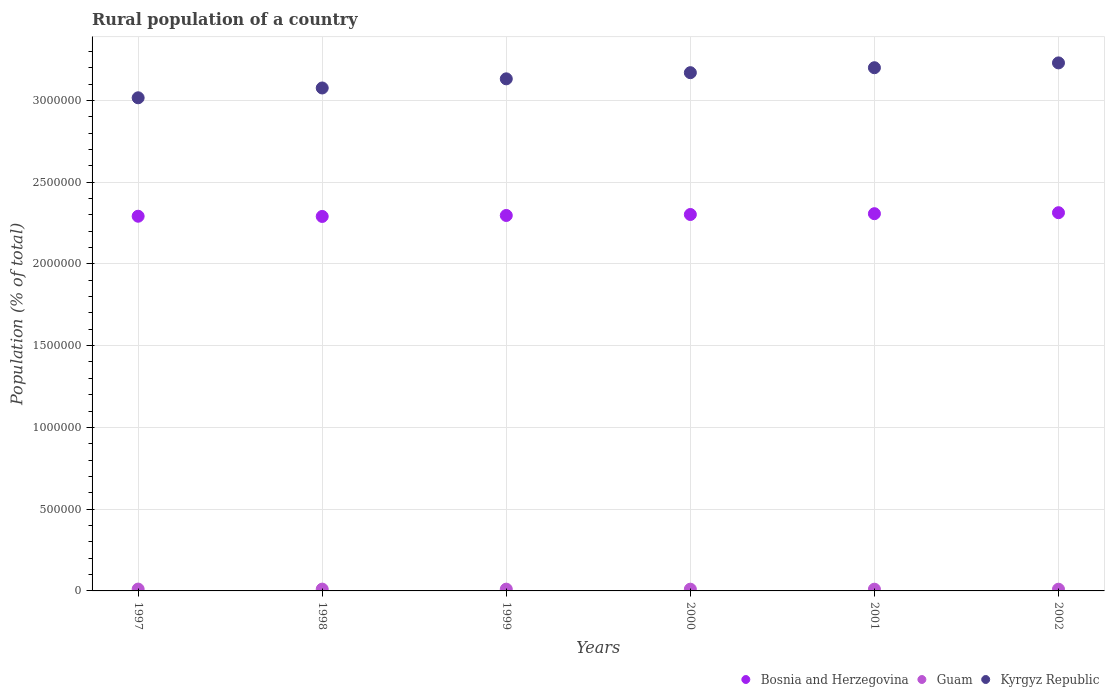How many different coloured dotlines are there?
Offer a very short reply. 3. Is the number of dotlines equal to the number of legend labels?
Keep it short and to the point. Yes. What is the rural population in Kyrgyz Republic in 2001?
Offer a very short reply. 3.20e+06. Across all years, what is the maximum rural population in Bosnia and Herzegovina?
Provide a succinct answer. 2.31e+06. Across all years, what is the minimum rural population in Kyrgyz Republic?
Ensure brevity in your answer.  3.02e+06. What is the total rural population in Bosnia and Herzegovina in the graph?
Provide a succinct answer. 1.38e+07. What is the difference between the rural population in Kyrgyz Republic in 1998 and that in 2002?
Make the answer very short. -1.53e+05. What is the difference between the rural population in Bosnia and Herzegovina in 1999 and the rural population in Kyrgyz Republic in 2000?
Your answer should be compact. -8.73e+05. What is the average rural population in Guam per year?
Your answer should be compact. 1.08e+04. In the year 1999, what is the difference between the rural population in Guam and rural population in Kyrgyz Republic?
Provide a short and direct response. -3.12e+06. What is the ratio of the rural population in Kyrgyz Republic in 1999 to that in 2001?
Keep it short and to the point. 0.98. Is the difference between the rural population in Guam in 1998 and 2000 greater than the difference between the rural population in Kyrgyz Republic in 1998 and 2000?
Give a very brief answer. Yes. What is the difference between the highest and the second highest rural population in Bosnia and Herzegovina?
Provide a short and direct response. 6022. What is the difference between the highest and the lowest rural population in Guam?
Keep it short and to the point. 771. Is the sum of the rural population in Kyrgyz Republic in 1998 and 2000 greater than the maximum rural population in Bosnia and Herzegovina across all years?
Provide a succinct answer. Yes. Is it the case that in every year, the sum of the rural population in Guam and rural population in Kyrgyz Republic  is greater than the rural population in Bosnia and Herzegovina?
Your answer should be very brief. Yes. Does the rural population in Bosnia and Herzegovina monotonically increase over the years?
Provide a succinct answer. No. What is the difference between two consecutive major ticks on the Y-axis?
Give a very brief answer. 5.00e+05. Are the values on the major ticks of Y-axis written in scientific E-notation?
Offer a very short reply. No. Does the graph contain grids?
Your response must be concise. Yes. Where does the legend appear in the graph?
Your answer should be very brief. Bottom right. How are the legend labels stacked?
Offer a very short reply. Horizontal. What is the title of the graph?
Ensure brevity in your answer.  Rural population of a country. Does "Ghana" appear as one of the legend labels in the graph?
Offer a very short reply. No. What is the label or title of the Y-axis?
Make the answer very short. Population (% of total). What is the Population (% of total) in Bosnia and Herzegovina in 1997?
Your answer should be very brief. 2.29e+06. What is the Population (% of total) of Guam in 1997?
Make the answer very short. 1.13e+04. What is the Population (% of total) of Kyrgyz Republic in 1997?
Provide a short and direct response. 3.02e+06. What is the Population (% of total) of Bosnia and Herzegovina in 1998?
Keep it short and to the point. 2.29e+06. What is the Population (% of total) of Guam in 1998?
Offer a terse response. 1.11e+04. What is the Population (% of total) in Kyrgyz Republic in 1998?
Keep it short and to the point. 3.08e+06. What is the Population (% of total) in Bosnia and Herzegovina in 1999?
Offer a very short reply. 2.30e+06. What is the Population (% of total) in Guam in 1999?
Ensure brevity in your answer.  1.09e+04. What is the Population (% of total) in Kyrgyz Republic in 1999?
Ensure brevity in your answer.  3.13e+06. What is the Population (% of total) of Bosnia and Herzegovina in 2000?
Ensure brevity in your answer.  2.30e+06. What is the Population (% of total) in Guam in 2000?
Make the answer very short. 1.07e+04. What is the Population (% of total) in Kyrgyz Republic in 2000?
Your answer should be compact. 3.17e+06. What is the Population (% of total) of Bosnia and Herzegovina in 2001?
Give a very brief answer. 2.31e+06. What is the Population (% of total) of Guam in 2001?
Offer a terse response. 1.06e+04. What is the Population (% of total) of Kyrgyz Republic in 2001?
Offer a terse response. 3.20e+06. What is the Population (% of total) in Bosnia and Herzegovina in 2002?
Your answer should be very brief. 2.31e+06. What is the Population (% of total) of Guam in 2002?
Your answer should be compact. 1.05e+04. What is the Population (% of total) in Kyrgyz Republic in 2002?
Keep it short and to the point. 3.23e+06. Across all years, what is the maximum Population (% of total) of Bosnia and Herzegovina?
Make the answer very short. 2.31e+06. Across all years, what is the maximum Population (% of total) in Guam?
Offer a very short reply. 1.13e+04. Across all years, what is the maximum Population (% of total) in Kyrgyz Republic?
Keep it short and to the point. 3.23e+06. Across all years, what is the minimum Population (% of total) in Bosnia and Herzegovina?
Offer a terse response. 2.29e+06. Across all years, what is the minimum Population (% of total) in Guam?
Make the answer very short. 1.05e+04. Across all years, what is the minimum Population (% of total) of Kyrgyz Republic?
Your response must be concise. 3.02e+06. What is the total Population (% of total) in Bosnia and Herzegovina in the graph?
Your answer should be compact. 1.38e+07. What is the total Population (% of total) of Guam in the graph?
Make the answer very short. 6.49e+04. What is the total Population (% of total) of Kyrgyz Republic in the graph?
Your response must be concise. 1.88e+07. What is the difference between the Population (% of total) of Bosnia and Herzegovina in 1997 and that in 1998?
Your answer should be compact. 1302. What is the difference between the Population (% of total) in Guam in 1997 and that in 1998?
Give a very brief answer. 187. What is the difference between the Population (% of total) of Kyrgyz Republic in 1997 and that in 1998?
Offer a very short reply. -6.00e+04. What is the difference between the Population (% of total) of Bosnia and Herzegovina in 1997 and that in 1999?
Give a very brief answer. -4642. What is the difference between the Population (% of total) in Guam in 1997 and that in 1999?
Provide a succinct answer. 393. What is the difference between the Population (% of total) in Kyrgyz Republic in 1997 and that in 1999?
Make the answer very short. -1.16e+05. What is the difference between the Population (% of total) of Bosnia and Herzegovina in 1997 and that in 2000?
Your response must be concise. -1.06e+04. What is the difference between the Population (% of total) in Guam in 1997 and that in 2000?
Give a very brief answer. 580. What is the difference between the Population (% of total) in Kyrgyz Republic in 1997 and that in 2000?
Your answer should be very brief. -1.54e+05. What is the difference between the Population (% of total) in Bosnia and Herzegovina in 1997 and that in 2001?
Offer a terse response. -1.56e+04. What is the difference between the Population (% of total) of Guam in 1997 and that in 2001?
Keep it short and to the point. 668. What is the difference between the Population (% of total) of Kyrgyz Republic in 1997 and that in 2001?
Ensure brevity in your answer.  -1.84e+05. What is the difference between the Population (% of total) of Bosnia and Herzegovina in 1997 and that in 2002?
Offer a very short reply. -2.16e+04. What is the difference between the Population (% of total) in Guam in 1997 and that in 2002?
Give a very brief answer. 771. What is the difference between the Population (% of total) of Kyrgyz Republic in 1997 and that in 2002?
Provide a succinct answer. -2.13e+05. What is the difference between the Population (% of total) in Bosnia and Herzegovina in 1998 and that in 1999?
Make the answer very short. -5944. What is the difference between the Population (% of total) in Guam in 1998 and that in 1999?
Provide a succinct answer. 206. What is the difference between the Population (% of total) in Kyrgyz Republic in 1998 and that in 1999?
Provide a succinct answer. -5.59e+04. What is the difference between the Population (% of total) of Bosnia and Herzegovina in 1998 and that in 2000?
Provide a short and direct response. -1.19e+04. What is the difference between the Population (% of total) of Guam in 1998 and that in 2000?
Offer a terse response. 393. What is the difference between the Population (% of total) in Kyrgyz Republic in 1998 and that in 2000?
Ensure brevity in your answer.  -9.35e+04. What is the difference between the Population (% of total) in Bosnia and Herzegovina in 1998 and that in 2001?
Make the answer very short. -1.69e+04. What is the difference between the Population (% of total) in Guam in 1998 and that in 2001?
Provide a short and direct response. 481. What is the difference between the Population (% of total) in Kyrgyz Republic in 1998 and that in 2001?
Offer a very short reply. -1.24e+05. What is the difference between the Population (% of total) in Bosnia and Herzegovina in 1998 and that in 2002?
Provide a short and direct response. -2.29e+04. What is the difference between the Population (% of total) of Guam in 1998 and that in 2002?
Your answer should be compact. 584. What is the difference between the Population (% of total) of Kyrgyz Republic in 1998 and that in 2002?
Keep it short and to the point. -1.53e+05. What is the difference between the Population (% of total) of Bosnia and Herzegovina in 1999 and that in 2000?
Your response must be concise. -5947. What is the difference between the Population (% of total) in Guam in 1999 and that in 2000?
Keep it short and to the point. 187. What is the difference between the Population (% of total) in Kyrgyz Republic in 1999 and that in 2000?
Ensure brevity in your answer.  -3.76e+04. What is the difference between the Population (% of total) of Bosnia and Herzegovina in 1999 and that in 2001?
Ensure brevity in your answer.  -1.09e+04. What is the difference between the Population (% of total) in Guam in 1999 and that in 2001?
Offer a terse response. 275. What is the difference between the Population (% of total) of Kyrgyz Republic in 1999 and that in 2001?
Your answer should be compact. -6.79e+04. What is the difference between the Population (% of total) in Bosnia and Herzegovina in 1999 and that in 2002?
Provide a short and direct response. -1.69e+04. What is the difference between the Population (% of total) in Guam in 1999 and that in 2002?
Give a very brief answer. 378. What is the difference between the Population (% of total) of Kyrgyz Republic in 1999 and that in 2002?
Provide a short and direct response. -9.75e+04. What is the difference between the Population (% of total) of Bosnia and Herzegovina in 2000 and that in 2001?
Give a very brief answer. -4967. What is the difference between the Population (% of total) in Kyrgyz Republic in 2000 and that in 2001?
Give a very brief answer. -3.03e+04. What is the difference between the Population (% of total) in Bosnia and Herzegovina in 2000 and that in 2002?
Ensure brevity in your answer.  -1.10e+04. What is the difference between the Population (% of total) in Guam in 2000 and that in 2002?
Provide a succinct answer. 191. What is the difference between the Population (% of total) in Kyrgyz Republic in 2000 and that in 2002?
Your response must be concise. -5.99e+04. What is the difference between the Population (% of total) of Bosnia and Herzegovina in 2001 and that in 2002?
Give a very brief answer. -6022. What is the difference between the Population (% of total) in Guam in 2001 and that in 2002?
Provide a short and direct response. 103. What is the difference between the Population (% of total) of Kyrgyz Republic in 2001 and that in 2002?
Offer a very short reply. -2.96e+04. What is the difference between the Population (% of total) of Bosnia and Herzegovina in 1997 and the Population (% of total) of Guam in 1998?
Make the answer very short. 2.28e+06. What is the difference between the Population (% of total) in Bosnia and Herzegovina in 1997 and the Population (% of total) in Kyrgyz Republic in 1998?
Your response must be concise. -7.84e+05. What is the difference between the Population (% of total) of Guam in 1997 and the Population (% of total) of Kyrgyz Republic in 1998?
Your answer should be very brief. -3.06e+06. What is the difference between the Population (% of total) of Bosnia and Herzegovina in 1997 and the Population (% of total) of Guam in 1999?
Your response must be concise. 2.28e+06. What is the difference between the Population (% of total) of Bosnia and Herzegovina in 1997 and the Population (% of total) of Kyrgyz Republic in 1999?
Give a very brief answer. -8.40e+05. What is the difference between the Population (% of total) in Guam in 1997 and the Population (% of total) in Kyrgyz Republic in 1999?
Your response must be concise. -3.12e+06. What is the difference between the Population (% of total) in Bosnia and Herzegovina in 1997 and the Population (% of total) in Guam in 2000?
Ensure brevity in your answer.  2.28e+06. What is the difference between the Population (% of total) of Bosnia and Herzegovina in 1997 and the Population (% of total) of Kyrgyz Republic in 2000?
Offer a terse response. -8.78e+05. What is the difference between the Population (% of total) of Guam in 1997 and the Population (% of total) of Kyrgyz Republic in 2000?
Make the answer very short. -3.16e+06. What is the difference between the Population (% of total) of Bosnia and Herzegovina in 1997 and the Population (% of total) of Guam in 2001?
Your response must be concise. 2.28e+06. What is the difference between the Population (% of total) in Bosnia and Herzegovina in 1997 and the Population (% of total) in Kyrgyz Republic in 2001?
Your answer should be compact. -9.08e+05. What is the difference between the Population (% of total) in Guam in 1997 and the Population (% of total) in Kyrgyz Republic in 2001?
Your response must be concise. -3.19e+06. What is the difference between the Population (% of total) of Bosnia and Herzegovina in 1997 and the Population (% of total) of Guam in 2002?
Offer a very short reply. 2.28e+06. What is the difference between the Population (% of total) in Bosnia and Herzegovina in 1997 and the Population (% of total) in Kyrgyz Republic in 2002?
Your answer should be very brief. -9.38e+05. What is the difference between the Population (% of total) of Guam in 1997 and the Population (% of total) of Kyrgyz Republic in 2002?
Your answer should be compact. -3.22e+06. What is the difference between the Population (% of total) in Bosnia and Herzegovina in 1998 and the Population (% of total) in Guam in 1999?
Make the answer very short. 2.28e+06. What is the difference between the Population (% of total) in Bosnia and Herzegovina in 1998 and the Population (% of total) in Kyrgyz Republic in 1999?
Offer a terse response. -8.42e+05. What is the difference between the Population (% of total) in Guam in 1998 and the Population (% of total) in Kyrgyz Republic in 1999?
Ensure brevity in your answer.  -3.12e+06. What is the difference between the Population (% of total) in Bosnia and Herzegovina in 1998 and the Population (% of total) in Guam in 2000?
Provide a succinct answer. 2.28e+06. What is the difference between the Population (% of total) of Bosnia and Herzegovina in 1998 and the Population (% of total) of Kyrgyz Republic in 2000?
Your answer should be very brief. -8.79e+05. What is the difference between the Population (% of total) in Guam in 1998 and the Population (% of total) in Kyrgyz Republic in 2000?
Provide a succinct answer. -3.16e+06. What is the difference between the Population (% of total) of Bosnia and Herzegovina in 1998 and the Population (% of total) of Guam in 2001?
Offer a terse response. 2.28e+06. What is the difference between the Population (% of total) in Bosnia and Herzegovina in 1998 and the Population (% of total) in Kyrgyz Republic in 2001?
Keep it short and to the point. -9.10e+05. What is the difference between the Population (% of total) of Guam in 1998 and the Population (% of total) of Kyrgyz Republic in 2001?
Provide a short and direct response. -3.19e+06. What is the difference between the Population (% of total) of Bosnia and Herzegovina in 1998 and the Population (% of total) of Guam in 2002?
Provide a succinct answer. 2.28e+06. What is the difference between the Population (% of total) of Bosnia and Herzegovina in 1998 and the Population (% of total) of Kyrgyz Republic in 2002?
Make the answer very short. -9.39e+05. What is the difference between the Population (% of total) of Guam in 1998 and the Population (% of total) of Kyrgyz Republic in 2002?
Make the answer very short. -3.22e+06. What is the difference between the Population (% of total) in Bosnia and Herzegovina in 1999 and the Population (% of total) in Guam in 2000?
Ensure brevity in your answer.  2.29e+06. What is the difference between the Population (% of total) in Bosnia and Herzegovina in 1999 and the Population (% of total) in Kyrgyz Republic in 2000?
Provide a succinct answer. -8.73e+05. What is the difference between the Population (% of total) in Guam in 1999 and the Population (% of total) in Kyrgyz Republic in 2000?
Offer a very short reply. -3.16e+06. What is the difference between the Population (% of total) of Bosnia and Herzegovina in 1999 and the Population (% of total) of Guam in 2001?
Your answer should be compact. 2.29e+06. What is the difference between the Population (% of total) of Bosnia and Herzegovina in 1999 and the Population (% of total) of Kyrgyz Republic in 2001?
Your answer should be compact. -9.04e+05. What is the difference between the Population (% of total) of Guam in 1999 and the Population (% of total) of Kyrgyz Republic in 2001?
Ensure brevity in your answer.  -3.19e+06. What is the difference between the Population (% of total) in Bosnia and Herzegovina in 1999 and the Population (% of total) in Guam in 2002?
Provide a short and direct response. 2.29e+06. What is the difference between the Population (% of total) of Bosnia and Herzegovina in 1999 and the Population (% of total) of Kyrgyz Republic in 2002?
Provide a succinct answer. -9.33e+05. What is the difference between the Population (% of total) of Guam in 1999 and the Population (% of total) of Kyrgyz Republic in 2002?
Give a very brief answer. -3.22e+06. What is the difference between the Population (% of total) of Bosnia and Herzegovina in 2000 and the Population (% of total) of Guam in 2001?
Provide a short and direct response. 2.29e+06. What is the difference between the Population (% of total) in Bosnia and Herzegovina in 2000 and the Population (% of total) in Kyrgyz Republic in 2001?
Your answer should be compact. -8.98e+05. What is the difference between the Population (% of total) of Guam in 2000 and the Population (% of total) of Kyrgyz Republic in 2001?
Provide a short and direct response. -3.19e+06. What is the difference between the Population (% of total) of Bosnia and Herzegovina in 2000 and the Population (% of total) of Guam in 2002?
Your answer should be very brief. 2.29e+06. What is the difference between the Population (% of total) of Bosnia and Herzegovina in 2000 and the Population (% of total) of Kyrgyz Republic in 2002?
Give a very brief answer. -9.27e+05. What is the difference between the Population (% of total) in Guam in 2000 and the Population (% of total) in Kyrgyz Republic in 2002?
Offer a very short reply. -3.22e+06. What is the difference between the Population (% of total) of Bosnia and Herzegovina in 2001 and the Population (% of total) of Guam in 2002?
Offer a very short reply. 2.30e+06. What is the difference between the Population (% of total) in Bosnia and Herzegovina in 2001 and the Population (% of total) in Kyrgyz Republic in 2002?
Offer a very short reply. -9.22e+05. What is the difference between the Population (% of total) in Guam in 2001 and the Population (% of total) in Kyrgyz Republic in 2002?
Give a very brief answer. -3.22e+06. What is the average Population (% of total) of Bosnia and Herzegovina per year?
Your answer should be compact. 2.30e+06. What is the average Population (% of total) of Guam per year?
Offer a very short reply. 1.08e+04. What is the average Population (% of total) of Kyrgyz Republic per year?
Provide a short and direct response. 3.14e+06. In the year 1997, what is the difference between the Population (% of total) of Bosnia and Herzegovina and Population (% of total) of Guam?
Offer a very short reply. 2.28e+06. In the year 1997, what is the difference between the Population (% of total) of Bosnia and Herzegovina and Population (% of total) of Kyrgyz Republic?
Give a very brief answer. -7.24e+05. In the year 1997, what is the difference between the Population (% of total) of Guam and Population (% of total) of Kyrgyz Republic?
Your answer should be very brief. -3.00e+06. In the year 1998, what is the difference between the Population (% of total) of Bosnia and Herzegovina and Population (% of total) of Guam?
Your response must be concise. 2.28e+06. In the year 1998, what is the difference between the Population (% of total) in Bosnia and Herzegovina and Population (% of total) in Kyrgyz Republic?
Your answer should be compact. -7.86e+05. In the year 1998, what is the difference between the Population (% of total) in Guam and Population (% of total) in Kyrgyz Republic?
Offer a terse response. -3.06e+06. In the year 1999, what is the difference between the Population (% of total) in Bosnia and Herzegovina and Population (% of total) in Guam?
Provide a succinct answer. 2.29e+06. In the year 1999, what is the difference between the Population (% of total) in Bosnia and Herzegovina and Population (% of total) in Kyrgyz Republic?
Your answer should be very brief. -8.36e+05. In the year 1999, what is the difference between the Population (% of total) in Guam and Population (% of total) in Kyrgyz Republic?
Ensure brevity in your answer.  -3.12e+06. In the year 2000, what is the difference between the Population (% of total) of Bosnia and Herzegovina and Population (% of total) of Guam?
Your answer should be compact. 2.29e+06. In the year 2000, what is the difference between the Population (% of total) of Bosnia and Herzegovina and Population (% of total) of Kyrgyz Republic?
Ensure brevity in your answer.  -8.67e+05. In the year 2000, what is the difference between the Population (% of total) in Guam and Population (% of total) in Kyrgyz Republic?
Your response must be concise. -3.16e+06. In the year 2001, what is the difference between the Population (% of total) of Bosnia and Herzegovina and Population (% of total) of Guam?
Give a very brief answer. 2.30e+06. In the year 2001, what is the difference between the Population (% of total) in Bosnia and Herzegovina and Population (% of total) in Kyrgyz Republic?
Provide a short and direct response. -8.93e+05. In the year 2001, what is the difference between the Population (% of total) in Guam and Population (% of total) in Kyrgyz Republic?
Your answer should be very brief. -3.19e+06. In the year 2002, what is the difference between the Population (% of total) in Bosnia and Herzegovina and Population (% of total) in Guam?
Keep it short and to the point. 2.30e+06. In the year 2002, what is the difference between the Population (% of total) of Bosnia and Herzegovina and Population (% of total) of Kyrgyz Republic?
Provide a short and direct response. -9.16e+05. In the year 2002, what is the difference between the Population (% of total) of Guam and Population (% of total) of Kyrgyz Republic?
Keep it short and to the point. -3.22e+06. What is the ratio of the Population (% of total) of Bosnia and Herzegovina in 1997 to that in 1998?
Give a very brief answer. 1. What is the ratio of the Population (% of total) in Guam in 1997 to that in 1998?
Provide a succinct answer. 1.02. What is the ratio of the Population (% of total) of Kyrgyz Republic in 1997 to that in 1998?
Make the answer very short. 0.98. What is the ratio of the Population (% of total) of Guam in 1997 to that in 1999?
Your answer should be very brief. 1.04. What is the ratio of the Population (% of total) of Bosnia and Herzegovina in 1997 to that in 2000?
Keep it short and to the point. 1. What is the ratio of the Population (% of total) of Guam in 1997 to that in 2000?
Keep it short and to the point. 1.05. What is the ratio of the Population (% of total) in Kyrgyz Republic in 1997 to that in 2000?
Your response must be concise. 0.95. What is the ratio of the Population (% of total) of Bosnia and Herzegovina in 1997 to that in 2001?
Your answer should be very brief. 0.99. What is the ratio of the Population (% of total) of Guam in 1997 to that in 2001?
Provide a short and direct response. 1.06. What is the ratio of the Population (% of total) of Kyrgyz Republic in 1997 to that in 2001?
Your answer should be very brief. 0.94. What is the ratio of the Population (% of total) in Bosnia and Herzegovina in 1997 to that in 2002?
Offer a very short reply. 0.99. What is the ratio of the Population (% of total) of Guam in 1997 to that in 2002?
Provide a short and direct response. 1.07. What is the ratio of the Population (% of total) of Kyrgyz Republic in 1997 to that in 2002?
Ensure brevity in your answer.  0.93. What is the ratio of the Population (% of total) in Bosnia and Herzegovina in 1998 to that in 1999?
Make the answer very short. 1. What is the ratio of the Population (% of total) of Guam in 1998 to that in 1999?
Offer a terse response. 1.02. What is the ratio of the Population (% of total) in Kyrgyz Republic in 1998 to that in 1999?
Your response must be concise. 0.98. What is the ratio of the Population (% of total) of Guam in 1998 to that in 2000?
Your response must be concise. 1.04. What is the ratio of the Population (% of total) of Kyrgyz Republic in 1998 to that in 2000?
Provide a short and direct response. 0.97. What is the ratio of the Population (% of total) in Guam in 1998 to that in 2001?
Make the answer very short. 1.05. What is the ratio of the Population (% of total) of Kyrgyz Republic in 1998 to that in 2001?
Provide a short and direct response. 0.96. What is the ratio of the Population (% of total) of Bosnia and Herzegovina in 1998 to that in 2002?
Your response must be concise. 0.99. What is the ratio of the Population (% of total) in Guam in 1998 to that in 2002?
Give a very brief answer. 1.06. What is the ratio of the Population (% of total) of Kyrgyz Republic in 1998 to that in 2002?
Provide a succinct answer. 0.95. What is the ratio of the Population (% of total) in Guam in 1999 to that in 2000?
Make the answer very short. 1.02. What is the ratio of the Population (% of total) in Bosnia and Herzegovina in 1999 to that in 2001?
Make the answer very short. 1. What is the ratio of the Population (% of total) in Kyrgyz Republic in 1999 to that in 2001?
Ensure brevity in your answer.  0.98. What is the ratio of the Population (% of total) in Bosnia and Herzegovina in 1999 to that in 2002?
Your answer should be very brief. 0.99. What is the ratio of the Population (% of total) in Guam in 1999 to that in 2002?
Your answer should be very brief. 1.04. What is the ratio of the Population (% of total) in Kyrgyz Republic in 1999 to that in 2002?
Provide a short and direct response. 0.97. What is the ratio of the Population (% of total) of Bosnia and Herzegovina in 2000 to that in 2001?
Your answer should be compact. 1. What is the ratio of the Population (% of total) of Guam in 2000 to that in 2001?
Ensure brevity in your answer.  1.01. What is the ratio of the Population (% of total) in Guam in 2000 to that in 2002?
Your response must be concise. 1.02. What is the ratio of the Population (% of total) of Kyrgyz Republic in 2000 to that in 2002?
Your answer should be compact. 0.98. What is the ratio of the Population (% of total) in Guam in 2001 to that in 2002?
Ensure brevity in your answer.  1.01. What is the difference between the highest and the second highest Population (% of total) of Bosnia and Herzegovina?
Make the answer very short. 6022. What is the difference between the highest and the second highest Population (% of total) in Guam?
Provide a succinct answer. 187. What is the difference between the highest and the second highest Population (% of total) in Kyrgyz Republic?
Keep it short and to the point. 2.96e+04. What is the difference between the highest and the lowest Population (% of total) in Bosnia and Herzegovina?
Give a very brief answer. 2.29e+04. What is the difference between the highest and the lowest Population (% of total) in Guam?
Ensure brevity in your answer.  771. What is the difference between the highest and the lowest Population (% of total) of Kyrgyz Republic?
Ensure brevity in your answer.  2.13e+05. 